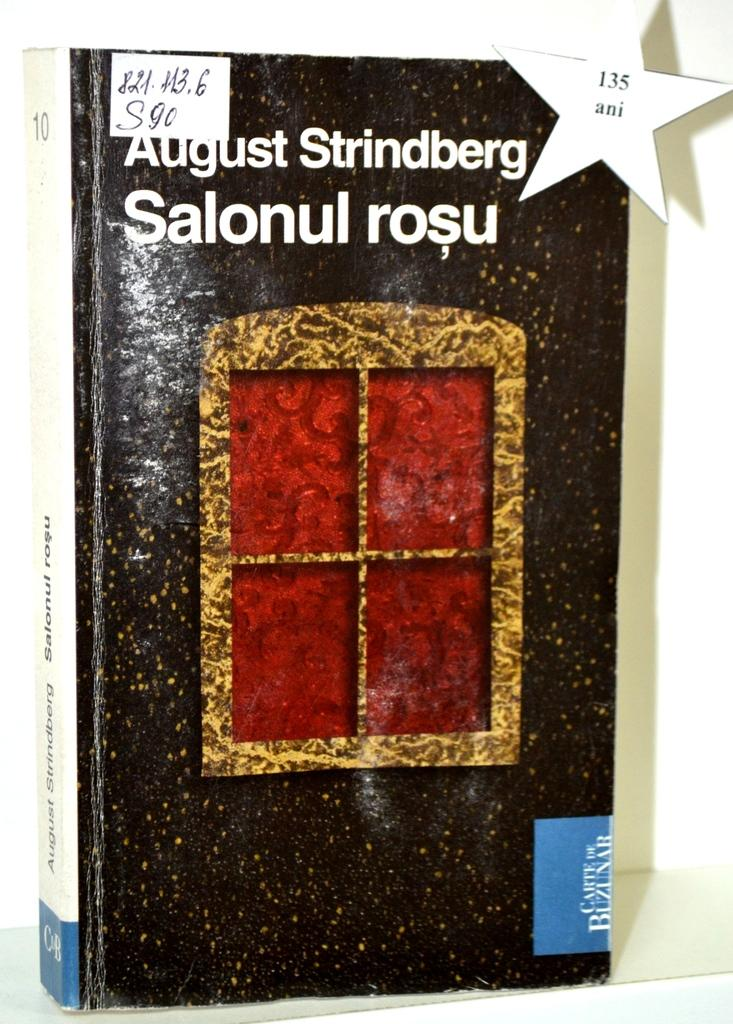Provide a one-sentence caption for the provided image. A hardcover copy of Salonul Rose by August Strindberg. 